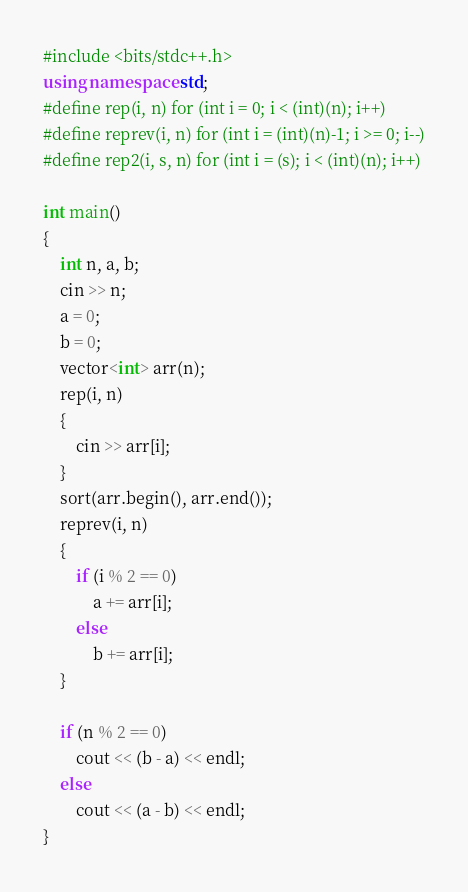Convert code to text. <code><loc_0><loc_0><loc_500><loc_500><_C++_>#include <bits/stdc++.h>
using namespace std;
#define rep(i, n) for (int i = 0; i < (int)(n); i++)
#define reprev(i, n) for (int i = (int)(n)-1; i >= 0; i--)
#define rep2(i, s, n) for (int i = (s); i < (int)(n); i++)

int main()
{
    int n, a, b;
    cin >> n;
    a = 0;
    b = 0;
    vector<int> arr(n);
    rep(i, n)
    {
        cin >> arr[i];
    }
    sort(arr.begin(), arr.end());
    reprev(i, n)
    {
        if (i % 2 == 0)
            a += arr[i];
        else
            b += arr[i];
    }

    if (n % 2 == 0)
        cout << (b - a) << endl;
    else
        cout << (a - b) << endl;
}</code> 